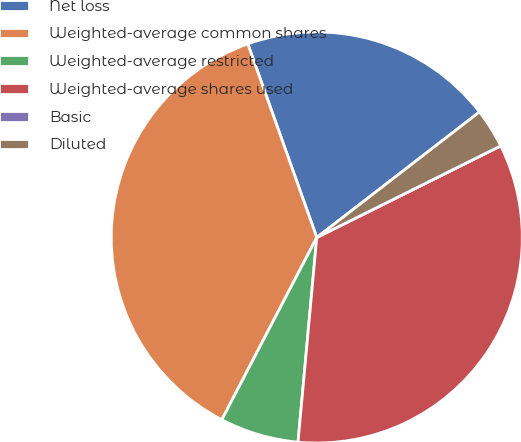Convert chart to OTSL. <chart><loc_0><loc_0><loc_500><loc_500><pie_chart><fcel>Net loss<fcel>Weighted-average common shares<fcel>Weighted-average restricted<fcel>Weighted-average shares used<fcel>Basic<fcel>Diluted<nl><fcel>19.99%<fcel>36.91%<fcel>6.19%<fcel>33.81%<fcel>0.0%<fcel>3.1%<nl></chart> 